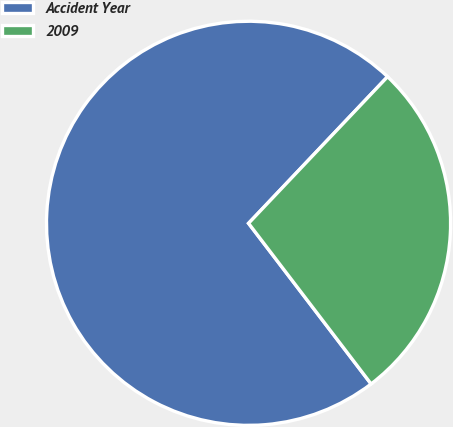Convert chart to OTSL. <chart><loc_0><loc_0><loc_500><loc_500><pie_chart><fcel>Accident Year<fcel>2009<nl><fcel>72.45%<fcel>27.55%<nl></chart> 